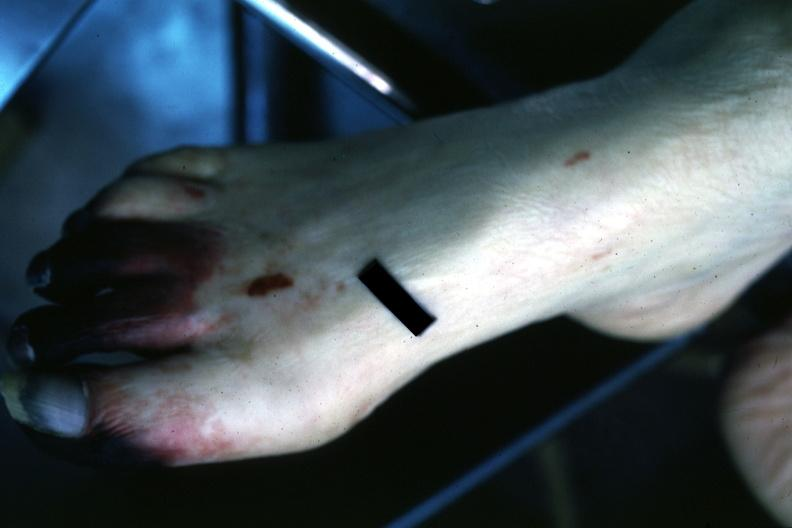re extremities present?
Answer the question using a single word or phrase. Yes 